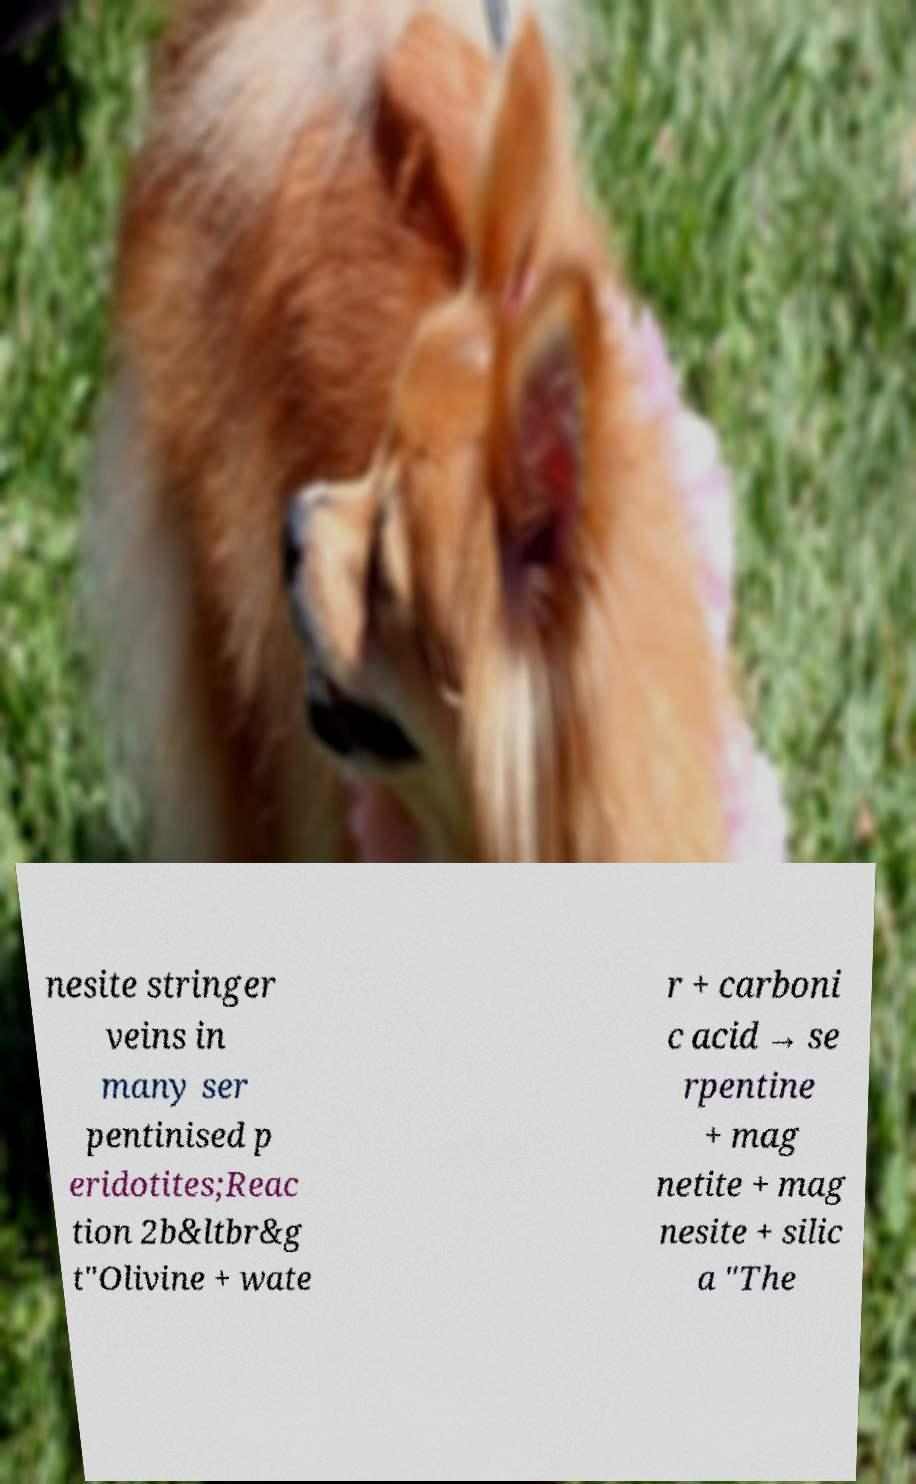Could you assist in decoding the text presented in this image and type it out clearly? nesite stringer veins in many ser pentinised p eridotites;Reac tion 2b&ltbr&g t"Olivine + wate r + carboni c acid → se rpentine + mag netite + mag nesite + silic a "The 